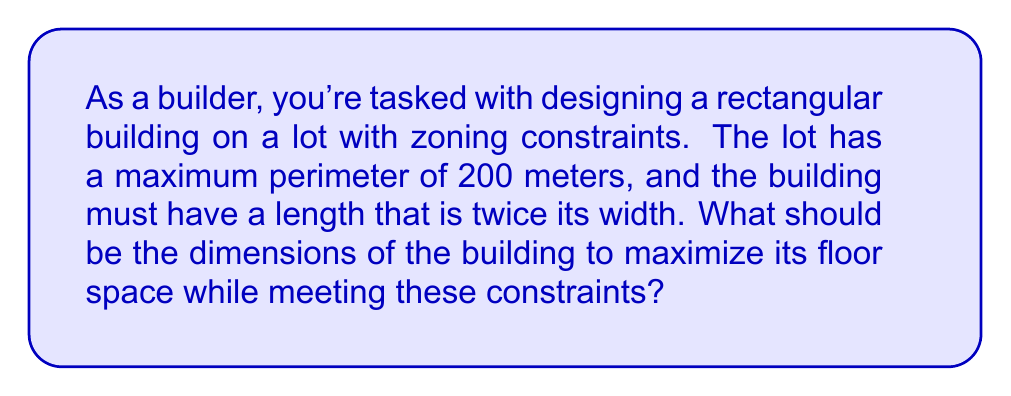What is the answer to this math problem? Let's approach this step-by-step:

1) Let $w$ be the width and $l$ be the length of the building.

2) Given that the length is twice the width: $l = 2w$

3) The perimeter constraint can be expressed as:
   $2w + 2l \leq 200$

4) Substituting $l = 2w$ into the perimeter constraint:
   $2w + 2(2w) \leq 200$
   $2w + 4w \leq 200$
   $6w \leq 200$

5) Solving for the maximum width:
   $w \leq \frac{200}{6} \approx 33.33$

6) The area of the building is given by $A = w \cdot l = w \cdot 2w = 2w^2$

7) To maximize the area, we want to use the maximum allowable width:
   $w = \frac{200}{6} \approx 33.33$ meters

8) The corresponding length is:
   $l = 2w = 2 \cdot \frac{200}{6} \approx 66.67$ meters

9) We can verify that this satisfies the perimeter constraint:
   $2w + 2l = 2(33.33) + 2(66.67) = 200$ meters

Therefore, the optimal dimensions are approximately 33.33 meters wide and 66.67 meters long.
Answer: Width: $\frac{200}{6}$ m, Length: $\frac{400}{6}$ m 